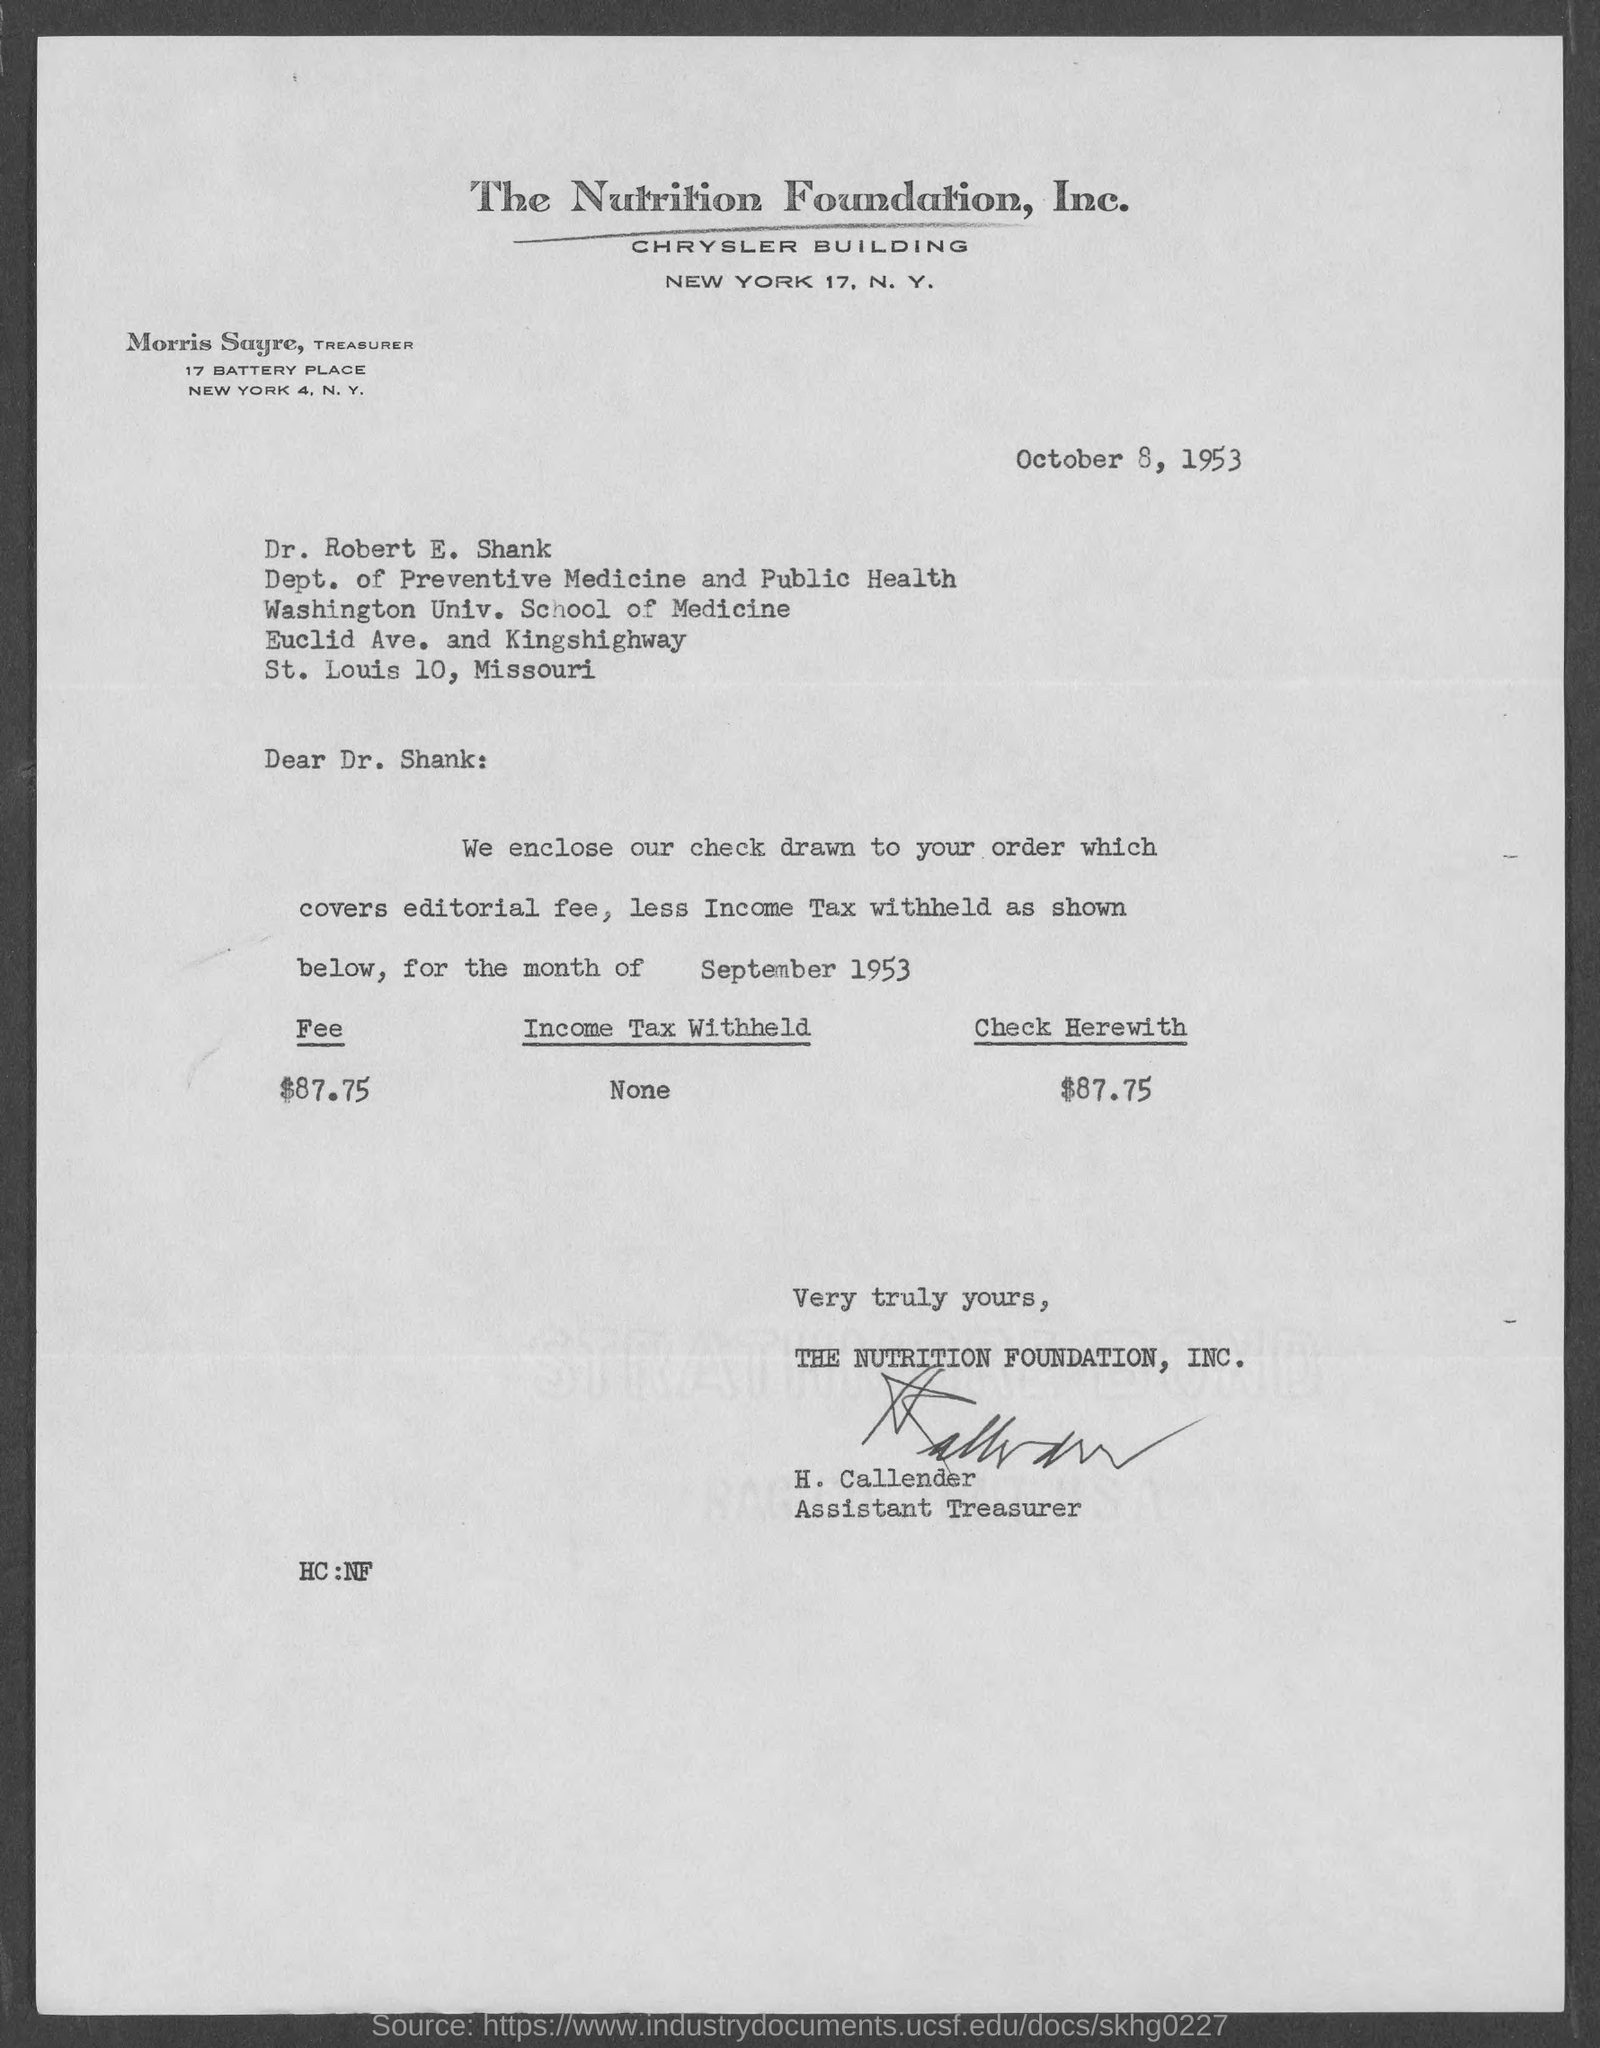What is the date mentioned in this letter?
Offer a terse response. October 8, 1953. Which company is mentioned in the letter head?
Your answer should be very brief. The Nutrition Foundation, Inc. Who has signed the letter?
Offer a very short reply. H. Callender. What is the amount of income tax withheld mentioned in the letter?
Your answer should be compact. None. How much is the editorial fee as per the letter?
Keep it short and to the point. $87.75. What is the amount of check mentioned in the letter?
Ensure brevity in your answer.  $87.75. 